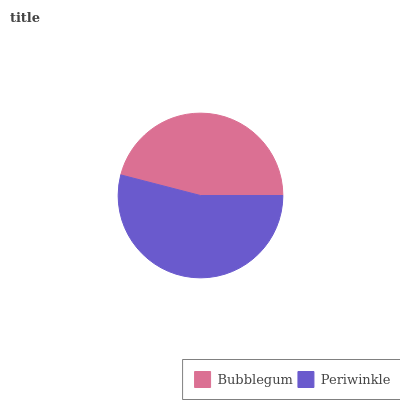Is Bubblegum the minimum?
Answer yes or no. Yes. Is Periwinkle the maximum?
Answer yes or no. Yes. Is Periwinkle the minimum?
Answer yes or no. No. Is Periwinkle greater than Bubblegum?
Answer yes or no. Yes. Is Bubblegum less than Periwinkle?
Answer yes or no. Yes. Is Bubblegum greater than Periwinkle?
Answer yes or no. No. Is Periwinkle less than Bubblegum?
Answer yes or no. No. Is Periwinkle the high median?
Answer yes or no. Yes. Is Bubblegum the low median?
Answer yes or no. Yes. Is Bubblegum the high median?
Answer yes or no. No. Is Periwinkle the low median?
Answer yes or no. No. 